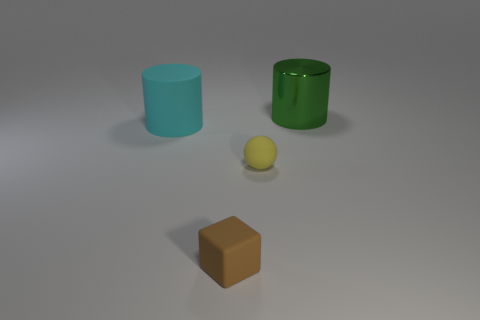Add 4 tiny spheres. How many objects exist? 8 Subtract all balls. How many objects are left? 3 Subtract all balls. Subtract all cylinders. How many objects are left? 1 Add 3 spheres. How many spheres are left? 4 Add 2 big matte cylinders. How many big matte cylinders exist? 3 Subtract 0 cyan blocks. How many objects are left? 4 